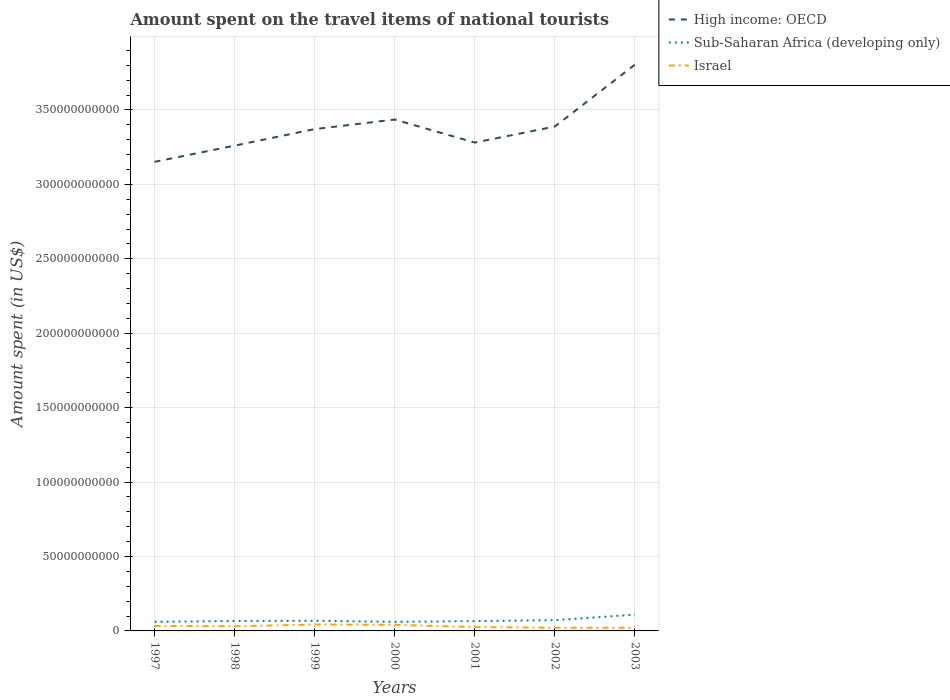How many different coloured lines are there?
Ensure brevity in your answer.  3. Is the number of lines equal to the number of legend labels?
Make the answer very short. Yes. Across all years, what is the maximum amount spent on the travel items of national tourists in Israel?
Offer a terse response. 2.13e+09. In which year was the amount spent on the travel items of national tourists in Israel maximum?
Your answer should be compact. 2003. What is the total amount spent on the travel items of national tourists in Israel in the graph?
Offer a very short reply. -1.15e+09. What is the difference between the highest and the second highest amount spent on the travel items of national tourists in Israel?
Ensure brevity in your answer.  2.17e+09. What is the difference between the highest and the lowest amount spent on the travel items of national tourists in Israel?
Offer a very short reply. 4. How many years are there in the graph?
Your answer should be compact. 7. What is the difference between two consecutive major ticks on the Y-axis?
Your answer should be compact. 5.00e+1. How many legend labels are there?
Provide a short and direct response. 3. How are the legend labels stacked?
Your response must be concise. Vertical. What is the title of the graph?
Give a very brief answer. Amount spent on the travel items of national tourists. What is the label or title of the Y-axis?
Offer a very short reply. Amount spent (in US$). What is the Amount spent (in US$) of High income: OECD in 1997?
Offer a terse response. 3.15e+11. What is the Amount spent (in US$) of Sub-Saharan Africa (developing only) in 1997?
Provide a short and direct response. 6.13e+09. What is the Amount spent (in US$) of Israel in 1997?
Ensure brevity in your answer.  3.30e+09. What is the Amount spent (in US$) of High income: OECD in 1998?
Make the answer very short. 3.26e+11. What is the Amount spent (in US$) in Sub-Saharan Africa (developing only) in 1998?
Keep it short and to the point. 6.64e+09. What is the Amount spent (in US$) in Israel in 1998?
Offer a very short reply. 3.16e+09. What is the Amount spent (in US$) of High income: OECD in 1999?
Make the answer very short. 3.37e+11. What is the Amount spent (in US$) in Sub-Saharan Africa (developing only) in 1999?
Your answer should be very brief. 6.82e+09. What is the Amount spent (in US$) in Israel in 1999?
Offer a very short reply. 4.30e+09. What is the Amount spent (in US$) in High income: OECD in 2000?
Provide a succinct answer. 3.44e+11. What is the Amount spent (in US$) in Sub-Saharan Africa (developing only) in 2000?
Your answer should be very brief. 6.09e+09. What is the Amount spent (in US$) of Israel in 2000?
Provide a short and direct response. 4.11e+09. What is the Amount spent (in US$) of High income: OECD in 2001?
Offer a very short reply. 3.28e+11. What is the Amount spent (in US$) in Sub-Saharan Africa (developing only) in 2001?
Ensure brevity in your answer.  6.57e+09. What is the Amount spent (in US$) of Israel in 2001?
Offer a very short reply. 2.56e+09. What is the Amount spent (in US$) in High income: OECD in 2002?
Keep it short and to the point. 3.39e+11. What is the Amount spent (in US$) of Sub-Saharan Africa (developing only) in 2002?
Your answer should be compact. 7.24e+09. What is the Amount spent (in US$) of Israel in 2002?
Ensure brevity in your answer.  2.14e+09. What is the Amount spent (in US$) in High income: OECD in 2003?
Make the answer very short. 3.80e+11. What is the Amount spent (in US$) of Sub-Saharan Africa (developing only) in 2003?
Your response must be concise. 1.09e+1. What is the Amount spent (in US$) in Israel in 2003?
Ensure brevity in your answer.  2.13e+09. Across all years, what is the maximum Amount spent (in US$) of High income: OECD?
Give a very brief answer. 3.80e+11. Across all years, what is the maximum Amount spent (in US$) in Sub-Saharan Africa (developing only)?
Your answer should be very brief. 1.09e+1. Across all years, what is the maximum Amount spent (in US$) of Israel?
Your answer should be compact. 4.30e+09. Across all years, what is the minimum Amount spent (in US$) of High income: OECD?
Your answer should be compact. 3.15e+11. Across all years, what is the minimum Amount spent (in US$) of Sub-Saharan Africa (developing only)?
Your answer should be compact. 6.09e+09. Across all years, what is the minimum Amount spent (in US$) in Israel?
Keep it short and to the point. 2.13e+09. What is the total Amount spent (in US$) of High income: OECD in the graph?
Offer a very short reply. 2.37e+12. What is the total Amount spent (in US$) in Sub-Saharan Africa (developing only) in the graph?
Your answer should be very brief. 5.04e+1. What is the total Amount spent (in US$) of Israel in the graph?
Your answer should be very brief. 2.17e+1. What is the difference between the Amount spent (in US$) in High income: OECD in 1997 and that in 1998?
Provide a short and direct response. -1.09e+1. What is the difference between the Amount spent (in US$) of Sub-Saharan Africa (developing only) in 1997 and that in 1998?
Give a very brief answer. -5.08e+08. What is the difference between the Amount spent (in US$) of Israel in 1997 and that in 1998?
Your answer should be very brief. 1.38e+08. What is the difference between the Amount spent (in US$) in High income: OECD in 1997 and that in 1999?
Ensure brevity in your answer.  -2.20e+1. What is the difference between the Amount spent (in US$) of Sub-Saharan Africa (developing only) in 1997 and that in 1999?
Offer a very short reply. -6.85e+08. What is the difference between the Amount spent (in US$) of Israel in 1997 and that in 1999?
Ensure brevity in your answer.  -1.01e+09. What is the difference between the Amount spent (in US$) in High income: OECD in 1997 and that in 2000?
Ensure brevity in your answer.  -2.84e+1. What is the difference between the Amount spent (in US$) in Sub-Saharan Africa (developing only) in 1997 and that in 2000?
Provide a short and direct response. 3.96e+07. What is the difference between the Amount spent (in US$) in Israel in 1997 and that in 2000?
Your response must be concise. -8.19e+08. What is the difference between the Amount spent (in US$) in High income: OECD in 1997 and that in 2001?
Your answer should be very brief. -1.30e+1. What is the difference between the Amount spent (in US$) of Sub-Saharan Africa (developing only) in 1997 and that in 2001?
Your answer should be very brief. -4.36e+08. What is the difference between the Amount spent (in US$) of Israel in 1997 and that in 2001?
Your response must be concise. 7.35e+08. What is the difference between the Amount spent (in US$) of High income: OECD in 1997 and that in 2002?
Provide a succinct answer. -2.37e+1. What is the difference between the Amount spent (in US$) of Sub-Saharan Africa (developing only) in 1997 and that in 2002?
Make the answer very short. -1.10e+09. What is the difference between the Amount spent (in US$) of Israel in 1997 and that in 2002?
Make the answer very short. 1.15e+09. What is the difference between the Amount spent (in US$) in High income: OECD in 1997 and that in 2003?
Provide a succinct answer. -6.53e+1. What is the difference between the Amount spent (in US$) in Sub-Saharan Africa (developing only) in 1997 and that in 2003?
Provide a short and direct response. -4.78e+09. What is the difference between the Amount spent (in US$) of Israel in 1997 and that in 2003?
Offer a terse response. 1.16e+09. What is the difference between the Amount spent (in US$) of High income: OECD in 1998 and that in 1999?
Keep it short and to the point. -1.11e+1. What is the difference between the Amount spent (in US$) in Sub-Saharan Africa (developing only) in 1998 and that in 1999?
Offer a very short reply. -1.77e+08. What is the difference between the Amount spent (in US$) of Israel in 1998 and that in 1999?
Provide a short and direct response. -1.15e+09. What is the difference between the Amount spent (in US$) of High income: OECD in 1998 and that in 2000?
Your response must be concise. -1.75e+1. What is the difference between the Amount spent (in US$) of Sub-Saharan Africa (developing only) in 1998 and that in 2000?
Your answer should be compact. 5.47e+08. What is the difference between the Amount spent (in US$) in Israel in 1998 and that in 2000?
Provide a short and direct response. -9.57e+08. What is the difference between the Amount spent (in US$) of High income: OECD in 1998 and that in 2001?
Keep it short and to the point. -2.06e+09. What is the difference between the Amount spent (in US$) of Sub-Saharan Africa (developing only) in 1998 and that in 2001?
Your answer should be very brief. 7.14e+07. What is the difference between the Amount spent (in US$) in Israel in 1998 and that in 2001?
Offer a terse response. 5.97e+08. What is the difference between the Amount spent (in US$) of High income: OECD in 1998 and that in 2002?
Offer a terse response. -1.28e+1. What is the difference between the Amount spent (in US$) in Sub-Saharan Africa (developing only) in 1998 and that in 2002?
Your answer should be compact. -5.95e+08. What is the difference between the Amount spent (in US$) in Israel in 1998 and that in 2002?
Offer a terse response. 1.01e+09. What is the difference between the Amount spent (in US$) of High income: OECD in 1998 and that in 2003?
Keep it short and to the point. -5.44e+1. What is the difference between the Amount spent (in US$) of Sub-Saharan Africa (developing only) in 1998 and that in 2003?
Offer a terse response. -4.27e+09. What is the difference between the Amount spent (in US$) in Israel in 1998 and that in 2003?
Ensure brevity in your answer.  1.02e+09. What is the difference between the Amount spent (in US$) of High income: OECD in 1999 and that in 2000?
Give a very brief answer. -6.42e+09. What is the difference between the Amount spent (in US$) in Sub-Saharan Africa (developing only) in 1999 and that in 2000?
Your response must be concise. 7.25e+08. What is the difference between the Amount spent (in US$) in Israel in 1999 and that in 2000?
Give a very brief answer. 1.90e+08. What is the difference between the Amount spent (in US$) of High income: OECD in 1999 and that in 2001?
Give a very brief answer. 9.06e+09. What is the difference between the Amount spent (in US$) of Sub-Saharan Africa (developing only) in 1999 and that in 2001?
Provide a succinct answer. 2.49e+08. What is the difference between the Amount spent (in US$) in Israel in 1999 and that in 2001?
Your answer should be very brief. 1.74e+09. What is the difference between the Amount spent (in US$) of High income: OECD in 1999 and that in 2002?
Ensure brevity in your answer.  -1.72e+09. What is the difference between the Amount spent (in US$) of Sub-Saharan Africa (developing only) in 1999 and that in 2002?
Ensure brevity in your answer.  -4.17e+08. What is the difference between the Amount spent (in US$) of Israel in 1999 and that in 2002?
Offer a terse response. 2.16e+09. What is the difference between the Amount spent (in US$) in High income: OECD in 1999 and that in 2003?
Give a very brief answer. -4.32e+1. What is the difference between the Amount spent (in US$) in Sub-Saharan Africa (developing only) in 1999 and that in 2003?
Offer a terse response. -4.10e+09. What is the difference between the Amount spent (in US$) in Israel in 1999 and that in 2003?
Offer a very short reply. 2.17e+09. What is the difference between the Amount spent (in US$) in High income: OECD in 2000 and that in 2001?
Give a very brief answer. 1.55e+1. What is the difference between the Amount spent (in US$) in Sub-Saharan Africa (developing only) in 2000 and that in 2001?
Offer a very short reply. -4.76e+08. What is the difference between the Amount spent (in US$) in Israel in 2000 and that in 2001?
Your answer should be compact. 1.55e+09. What is the difference between the Amount spent (in US$) of High income: OECD in 2000 and that in 2002?
Your answer should be compact. 4.70e+09. What is the difference between the Amount spent (in US$) of Sub-Saharan Africa (developing only) in 2000 and that in 2002?
Your answer should be compact. -1.14e+09. What is the difference between the Amount spent (in US$) of Israel in 2000 and that in 2002?
Ensure brevity in your answer.  1.97e+09. What is the difference between the Amount spent (in US$) in High income: OECD in 2000 and that in 2003?
Ensure brevity in your answer.  -3.68e+1. What is the difference between the Amount spent (in US$) in Sub-Saharan Africa (developing only) in 2000 and that in 2003?
Provide a short and direct response. -4.82e+09. What is the difference between the Amount spent (in US$) of Israel in 2000 and that in 2003?
Your answer should be compact. 1.98e+09. What is the difference between the Amount spent (in US$) of High income: OECD in 2001 and that in 2002?
Provide a succinct answer. -1.08e+1. What is the difference between the Amount spent (in US$) in Sub-Saharan Africa (developing only) in 2001 and that in 2002?
Give a very brief answer. -6.66e+08. What is the difference between the Amount spent (in US$) in Israel in 2001 and that in 2002?
Keep it short and to the point. 4.15e+08. What is the difference between the Amount spent (in US$) of High income: OECD in 2001 and that in 2003?
Keep it short and to the point. -5.23e+1. What is the difference between the Amount spent (in US$) of Sub-Saharan Africa (developing only) in 2001 and that in 2003?
Provide a short and direct response. -4.34e+09. What is the difference between the Amount spent (in US$) in Israel in 2001 and that in 2003?
Make the answer very short. 4.28e+08. What is the difference between the Amount spent (in US$) of High income: OECD in 2002 and that in 2003?
Ensure brevity in your answer.  -4.15e+1. What is the difference between the Amount spent (in US$) of Sub-Saharan Africa (developing only) in 2002 and that in 2003?
Your response must be concise. -3.68e+09. What is the difference between the Amount spent (in US$) of Israel in 2002 and that in 2003?
Provide a short and direct response. 1.30e+07. What is the difference between the Amount spent (in US$) of High income: OECD in 1997 and the Amount spent (in US$) of Sub-Saharan Africa (developing only) in 1998?
Provide a short and direct response. 3.08e+11. What is the difference between the Amount spent (in US$) of High income: OECD in 1997 and the Amount spent (in US$) of Israel in 1998?
Your answer should be compact. 3.12e+11. What is the difference between the Amount spent (in US$) of Sub-Saharan Africa (developing only) in 1997 and the Amount spent (in US$) of Israel in 1998?
Offer a very short reply. 2.98e+09. What is the difference between the Amount spent (in US$) of High income: OECD in 1997 and the Amount spent (in US$) of Sub-Saharan Africa (developing only) in 1999?
Ensure brevity in your answer.  3.08e+11. What is the difference between the Amount spent (in US$) of High income: OECD in 1997 and the Amount spent (in US$) of Israel in 1999?
Keep it short and to the point. 3.11e+11. What is the difference between the Amount spent (in US$) in Sub-Saharan Africa (developing only) in 1997 and the Amount spent (in US$) in Israel in 1999?
Provide a short and direct response. 1.83e+09. What is the difference between the Amount spent (in US$) in High income: OECD in 1997 and the Amount spent (in US$) in Sub-Saharan Africa (developing only) in 2000?
Ensure brevity in your answer.  3.09e+11. What is the difference between the Amount spent (in US$) of High income: OECD in 1997 and the Amount spent (in US$) of Israel in 2000?
Your answer should be very brief. 3.11e+11. What is the difference between the Amount spent (in US$) in Sub-Saharan Africa (developing only) in 1997 and the Amount spent (in US$) in Israel in 2000?
Provide a succinct answer. 2.02e+09. What is the difference between the Amount spent (in US$) in High income: OECD in 1997 and the Amount spent (in US$) in Sub-Saharan Africa (developing only) in 2001?
Make the answer very short. 3.09e+11. What is the difference between the Amount spent (in US$) of High income: OECD in 1997 and the Amount spent (in US$) of Israel in 2001?
Your response must be concise. 3.13e+11. What is the difference between the Amount spent (in US$) of Sub-Saharan Africa (developing only) in 1997 and the Amount spent (in US$) of Israel in 2001?
Provide a succinct answer. 3.57e+09. What is the difference between the Amount spent (in US$) of High income: OECD in 1997 and the Amount spent (in US$) of Sub-Saharan Africa (developing only) in 2002?
Ensure brevity in your answer.  3.08e+11. What is the difference between the Amount spent (in US$) in High income: OECD in 1997 and the Amount spent (in US$) in Israel in 2002?
Keep it short and to the point. 3.13e+11. What is the difference between the Amount spent (in US$) of Sub-Saharan Africa (developing only) in 1997 and the Amount spent (in US$) of Israel in 2002?
Ensure brevity in your answer.  3.99e+09. What is the difference between the Amount spent (in US$) of High income: OECD in 1997 and the Amount spent (in US$) of Sub-Saharan Africa (developing only) in 2003?
Provide a succinct answer. 3.04e+11. What is the difference between the Amount spent (in US$) in High income: OECD in 1997 and the Amount spent (in US$) in Israel in 2003?
Your answer should be compact. 3.13e+11. What is the difference between the Amount spent (in US$) of Sub-Saharan Africa (developing only) in 1997 and the Amount spent (in US$) of Israel in 2003?
Offer a very short reply. 4.00e+09. What is the difference between the Amount spent (in US$) of High income: OECD in 1998 and the Amount spent (in US$) of Sub-Saharan Africa (developing only) in 1999?
Your answer should be compact. 3.19e+11. What is the difference between the Amount spent (in US$) of High income: OECD in 1998 and the Amount spent (in US$) of Israel in 1999?
Offer a terse response. 3.22e+11. What is the difference between the Amount spent (in US$) in Sub-Saharan Africa (developing only) in 1998 and the Amount spent (in US$) in Israel in 1999?
Your answer should be compact. 2.34e+09. What is the difference between the Amount spent (in US$) in High income: OECD in 1998 and the Amount spent (in US$) in Sub-Saharan Africa (developing only) in 2000?
Your answer should be compact. 3.20e+11. What is the difference between the Amount spent (in US$) of High income: OECD in 1998 and the Amount spent (in US$) of Israel in 2000?
Give a very brief answer. 3.22e+11. What is the difference between the Amount spent (in US$) in Sub-Saharan Africa (developing only) in 1998 and the Amount spent (in US$) in Israel in 2000?
Give a very brief answer. 2.53e+09. What is the difference between the Amount spent (in US$) of High income: OECD in 1998 and the Amount spent (in US$) of Sub-Saharan Africa (developing only) in 2001?
Provide a succinct answer. 3.19e+11. What is the difference between the Amount spent (in US$) of High income: OECD in 1998 and the Amount spent (in US$) of Israel in 2001?
Give a very brief answer. 3.23e+11. What is the difference between the Amount spent (in US$) of Sub-Saharan Africa (developing only) in 1998 and the Amount spent (in US$) of Israel in 2001?
Offer a terse response. 4.08e+09. What is the difference between the Amount spent (in US$) of High income: OECD in 1998 and the Amount spent (in US$) of Sub-Saharan Africa (developing only) in 2002?
Your answer should be compact. 3.19e+11. What is the difference between the Amount spent (in US$) in High income: OECD in 1998 and the Amount spent (in US$) in Israel in 2002?
Make the answer very short. 3.24e+11. What is the difference between the Amount spent (in US$) of Sub-Saharan Africa (developing only) in 1998 and the Amount spent (in US$) of Israel in 2002?
Offer a terse response. 4.50e+09. What is the difference between the Amount spent (in US$) of High income: OECD in 1998 and the Amount spent (in US$) of Sub-Saharan Africa (developing only) in 2003?
Offer a terse response. 3.15e+11. What is the difference between the Amount spent (in US$) of High income: OECD in 1998 and the Amount spent (in US$) of Israel in 2003?
Ensure brevity in your answer.  3.24e+11. What is the difference between the Amount spent (in US$) of Sub-Saharan Africa (developing only) in 1998 and the Amount spent (in US$) of Israel in 2003?
Offer a very short reply. 4.51e+09. What is the difference between the Amount spent (in US$) of High income: OECD in 1999 and the Amount spent (in US$) of Sub-Saharan Africa (developing only) in 2000?
Ensure brevity in your answer.  3.31e+11. What is the difference between the Amount spent (in US$) of High income: OECD in 1999 and the Amount spent (in US$) of Israel in 2000?
Provide a succinct answer. 3.33e+11. What is the difference between the Amount spent (in US$) of Sub-Saharan Africa (developing only) in 1999 and the Amount spent (in US$) of Israel in 2000?
Your answer should be compact. 2.70e+09. What is the difference between the Amount spent (in US$) in High income: OECD in 1999 and the Amount spent (in US$) in Sub-Saharan Africa (developing only) in 2001?
Keep it short and to the point. 3.31e+11. What is the difference between the Amount spent (in US$) of High income: OECD in 1999 and the Amount spent (in US$) of Israel in 2001?
Give a very brief answer. 3.35e+11. What is the difference between the Amount spent (in US$) of Sub-Saharan Africa (developing only) in 1999 and the Amount spent (in US$) of Israel in 2001?
Offer a terse response. 4.26e+09. What is the difference between the Amount spent (in US$) in High income: OECD in 1999 and the Amount spent (in US$) in Sub-Saharan Africa (developing only) in 2002?
Provide a short and direct response. 3.30e+11. What is the difference between the Amount spent (in US$) of High income: OECD in 1999 and the Amount spent (in US$) of Israel in 2002?
Offer a terse response. 3.35e+11. What is the difference between the Amount spent (in US$) of Sub-Saharan Africa (developing only) in 1999 and the Amount spent (in US$) of Israel in 2002?
Your answer should be compact. 4.67e+09. What is the difference between the Amount spent (in US$) of High income: OECD in 1999 and the Amount spent (in US$) of Sub-Saharan Africa (developing only) in 2003?
Keep it short and to the point. 3.26e+11. What is the difference between the Amount spent (in US$) in High income: OECD in 1999 and the Amount spent (in US$) in Israel in 2003?
Offer a very short reply. 3.35e+11. What is the difference between the Amount spent (in US$) in Sub-Saharan Africa (developing only) in 1999 and the Amount spent (in US$) in Israel in 2003?
Give a very brief answer. 4.69e+09. What is the difference between the Amount spent (in US$) of High income: OECD in 2000 and the Amount spent (in US$) of Sub-Saharan Africa (developing only) in 2001?
Your answer should be compact. 3.37e+11. What is the difference between the Amount spent (in US$) in High income: OECD in 2000 and the Amount spent (in US$) in Israel in 2001?
Your answer should be very brief. 3.41e+11. What is the difference between the Amount spent (in US$) of Sub-Saharan Africa (developing only) in 2000 and the Amount spent (in US$) of Israel in 2001?
Your answer should be compact. 3.53e+09. What is the difference between the Amount spent (in US$) of High income: OECD in 2000 and the Amount spent (in US$) of Sub-Saharan Africa (developing only) in 2002?
Provide a short and direct response. 3.36e+11. What is the difference between the Amount spent (in US$) of High income: OECD in 2000 and the Amount spent (in US$) of Israel in 2002?
Make the answer very short. 3.41e+11. What is the difference between the Amount spent (in US$) of Sub-Saharan Africa (developing only) in 2000 and the Amount spent (in US$) of Israel in 2002?
Offer a terse response. 3.95e+09. What is the difference between the Amount spent (in US$) of High income: OECD in 2000 and the Amount spent (in US$) of Sub-Saharan Africa (developing only) in 2003?
Your response must be concise. 3.33e+11. What is the difference between the Amount spent (in US$) in High income: OECD in 2000 and the Amount spent (in US$) in Israel in 2003?
Your response must be concise. 3.41e+11. What is the difference between the Amount spent (in US$) of Sub-Saharan Africa (developing only) in 2000 and the Amount spent (in US$) of Israel in 2003?
Offer a very short reply. 3.96e+09. What is the difference between the Amount spent (in US$) of High income: OECD in 2001 and the Amount spent (in US$) of Sub-Saharan Africa (developing only) in 2002?
Your answer should be compact. 3.21e+11. What is the difference between the Amount spent (in US$) in High income: OECD in 2001 and the Amount spent (in US$) in Israel in 2002?
Your answer should be compact. 3.26e+11. What is the difference between the Amount spent (in US$) in Sub-Saharan Africa (developing only) in 2001 and the Amount spent (in US$) in Israel in 2002?
Ensure brevity in your answer.  4.42e+09. What is the difference between the Amount spent (in US$) of High income: OECD in 2001 and the Amount spent (in US$) of Sub-Saharan Africa (developing only) in 2003?
Your response must be concise. 3.17e+11. What is the difference between the Amount spent (in US$) of High income: OECD in 2001 and the Amount spent (in US$) of Israel in 2003?
Give a very brief answer. 3.26e+11. What is the difference between the Amount spent (in US$) in Sub-Saharan Africa (developing only) in 2001 and the Amount spent (in US$) in Israel in 2003?
Offer a terse response. 4.44e+09. What is the difference between the Amount spent (in US$) of High income: OECD in 2002 and the Amount spent (in US$) of Sub-Saharan Africa (developing only) in 2003?
Offer a very short reply. 3.28e+11. What is the difference between the Amount spent (in US$) of High income: OECD in 2002 and the Amount spent (in US$) of Israel in 2003?
Provide a short and direct response. 3.37e+11. What is the difference between the Amount spent (in US$) in Sub-Saharan Africa (developing only) in 2002 and the Amount spent (in US$) in Israel in 2003?
Make the answer very short. 5.10e+09. What is the average Amount spent (in US$) of High income: OECD per year?
Keep it short and to the point. 3.38e+11. What is the average Amount spent (in US$) in Sub-Saharan Africa (developing only) per year?
Make the answer very short. 7.20e+09. What is the average Amount spent (in US$) in Israel per year?
Ensure brevity in your answer.  3.10e+09. In the year 1997, what is the difference between the Amount spent (in US$) of High income: OECD and Amount spent (in US$) of Sub-Saharan Africa (developing only)?
Keep it short and to the point. 3.09e+11. In the year 1997, what is the difference between the Amount spent (in US$) in High income: OECD and Amount spent (in US$) in Israel?
Offer a very short reply. 3.12e+11. In the year 1997, what is the difference between the Amount spent (in US$) of Sub-Saharan Africa (developing only) and Amount spent (in US$) of Israel?
Ensure brevity in your answer.  2.84e+09. In the year 1998, what is the difference between the Amount spent (in US$) of High income: OECD and Amount spent (in US$) of Sub-Saharan Africa (developing only)?
Make the answer very short. 3.19e+11. In the year 1998, what is the difference between the Amount spent (in US$) of High income: OECD and Amount spent (in US$) of Israel?
Provide a short and direct response. 3.23e+11. In the year 1998, what is the difference between the Amount spent (in US$) in Sub-Saharan Africa (developing only) and Amount spent (in US$) in Israel?
Offer a terse response. 3.48e+09. In the year 1999, what is the difference between the Amount spent (in US$) of High income: OECD and Amount spent (in US$) of Sub-Saharan Africa (developing only)?
Keep it short and to the point. 3.30e+11. In the year 1999, what is the difference between the Amount spent (in US$) of High income: OECD and Amount spent (in US$) of Israel?
Your answer should be very brief. 3.33e+11. In the year 1999, what is the difference between the Amount spent (in US$) in Sub-Saharan Africa (developing only) and Amount spent (in US$) in Israel?
Your response must be concise. 2.51e+09. In the year 2000, what is the difference between the Amount spent (in US$) of High income: OECD and Amount spent (in US$) of Sub-Saharan Africa (developing only)?
Make the answer very short. 3.37e+11. In the year 2000, what is the difference between the Amount spent (in US$) of High income: OECD and Amount spent (in US$) of Israel?
Keep it short and to the point. 3.39e+11. In the year 2000, what is the difference between the Amount spent (in US$) of Sub-Saharan Africa (developing only) and Amount spent (in US$) of Israel?
Make the answer very short. 1.98e+09. In the year 2001, what is the difference between the Amount spent (in US$) in High income: OECD and Amount spent (in US$) in Sub-Saharan Africa (developing only)?
Your response must be concise. 3.21e+11. In the year 2001, what is the difference between the Amount spent (in US$) in High income: OECD and Amount spent (in US$) in Israel?
Provide a short and direct response. 3.26e+11. In the year 2001, what is the difference between the Amount spent (in US$) of Sub-Saharan Africa (developing only) and Amount spent (in US$) of Israel?
Your answer should be compact. 4.01e+09. In the year 2002, what is the difference between the Amount spent (in US$) in High income: OECD and Amount spent (in US$) in Sub-Saharan Africa (developing only)?
Provide a succinct answer. 3.32e+11. In the year 2002, what is the difference between the Amount spent (in US$) of High income: OECD and Amount spent (in US$) of Israel?
Offer a very short reply. 3.37e+11. In the year 2002, what is the difference between the Amount spent (in US$) of Sub-Saharan Africa (developing only) and Amount spent (in US$) of Israel?
Keep it short and to the point. 5.09e+09. In the year 2003, what is the difference between the Amount spent (in US$) in High income: OECD and Amount spent (in US$) in Sub-Saharan Africa (developing only)?
Your answer should be compact. 3.69e+11. In the year 2003, what is the difference between the Amount spent (in US$) of High income: OECD and Amount spent (in US$) of Israel?
Your answer should be compact. 3.78e+11. In the year 2003, what is the difference between the Amount spent (in US$) in Sub-Saharan Africa (developing only) and Amount spent (in US$) in Israel?
Make the answer very short. 8.78e+09. What is the ratio of the Amount spent (in US$) of High income: OECD in 1997 to that in 1998?
Keep it short and to the point. 0.97. What is the ratio of the Amount spent (in US$) in Sub-Saharan Africa (developing only) in 1997 to that in 1998?
Offer a very short reply. 0.92. What is the ratio of the Amount spent (in US$) of Israel in 1997 to that in 1998?
Provide a short and direct response. 1.04. What is the ratio of the Amount spent (in US$) of High income: OECD in 1997 to that in 1999?
Provide a short and direct response. 0.93. What is the ratio of the Amount spent (in US$) in Sub-Saharan Africa (developing only) in 1997 to that in 1999?
Provide a short and direct response. 0.9. What is the ratio of the Amount spent (in US$) of Israel in 1997 to that in 1999?
Your response must be concise. 0.77. What is the ratio of the Amount spent (in US$) in High income: OECD in 1997 to that in 2000?
Your answer should be compact. 0.92. What is the ratio of the Amount spent (in US$) of Israel in 1997 to that in 2000?
Ensure brevity in your answer.  0.8. What is the ratio of the Amount spent (in US$) of High income: OECD in 1997 to that in 2001?
Make the answer very short. 0.96. What is the ratio of the Amount spent (in US$) in Sub-Saharan Africa (developing only) in 1997 to that in 2001?
Make the answer very short. 0.93. What is the ratio of the Amount spent (in US$) in Israel in 1997 to that in 2001?
Offer a terse response. 1.29. What is the ratio of the Amount spent (in US$) in High income: OECD in 1997 to that in 2002?
Your answer should be very brief. 0.93. What is the ratio of the Amount spent (in US$) of Sub-Saharan Africa (developing only) in 1997 to that in 2002?
Provide a succinct answer. 0.85. What is the ratio of the Amount spent (in US$) of Israel in 1997 to that in 2002?
Keep it short and to the point. 1.54. What is the ratio of the Amount spent (in US$) in High income: OECD in 1997 to that in 2003?
Keep it short and to the point. 0.83. What is the ratio of the Amount spent (in US$) in Sub-Saharan Africa (developing only) in 1997 to that in 2003?
Offer a terse response. 0.56. What is the ratio of the Amount spent (in US$) in Israel in 1997 to that in 2003?
Ensure brevity in your answer.  1.55. What is the ratio of the Amount spent (in US$) of High income: OECD in 1998 to that in 1999?
Ensure brevity in your answer.  0.97. What is the ratio of the Amount spent (in US$) in Israel in 1998 to that in 1999?
Keep it short and to the point. 0.73. What is the ratio of the Amount spent (in US$) in High income: OECD in 1998 to that in 2000?
Give a very brief answer. 0.95. What is the ratio of the Amount spent (in US$) of Sub-Saharan Africa (developing only) in 1998 to that in 2000?
Provide a succinct answer. 1.09. What is the ratio of the Amount spent (in US$) in Israel in 1998 to that in 2000?
Offer a terse response. 0.77. What is the ratio of the Amount spent (in US$) in High income: OECD in 1998 to that in 2001?
Provide a short and direct response. 0.99. What is the ratio of the Amount spent (in US$) in Sub-Saharan Africa (developing only) in 1998 to that in 2001?
Provide a short and direct response. 1.01. What is the ratio of the Amount spent (in US$) of Israel in 1998 to that in 2001?
Make the answer very short. 1.23. What is the ratio of the Amount spent (in US$) in High income: OECD in 1998 to that in 2002?
Keep it short and to the point. 0.96. What is the ratio of the Amount spent (in US$) in Sub-Saharan Africa (developing only) in 1998 to that in 2002?
Ensure brevity in your answer.  0.92. What is the ratio of the Amount spent (in US$) of Israel in 1998 to that in 2002?
Provide a short and direct response. 1.47. What is the ratio of the Amount spent (in US$) of High income: OECD in 1998 to that in 2003?
Provide a short and direct response. 0.86. What is the ratio of the Amount spent (in US$) of Sub-Saharan Africa (developing only) in 1998 to that in 2003?
Make the answer very short. 0.61. What is the ratio of the Amount spent (in US$) in Israel in 1998 to that in 2003?
Your answer should be compact. 1.48. What is the ratio of the Amount spent (in US$) of High income: OECD in 1999 to that in 2000?
Offer a terse response. 0.98. What is the ratio of the Amount spent (in US$) in Sub-Saharan Africa (developing only) in 1999 to that in 2000?
Your response must be concise. 1.12. What is the ratio of the Amount spent (in US$) of Israel in 1999 to that in 2000?
Make the answer very short. 1.05. What is the ratio of the Amount spent (in US$) of High income: OECD in 1999 to that in 2001?
Keep it short and to the point. 1.03. What is the ratio of the Amount spent (in US$) in Sub-Saharan Africa (developing only) in 1999 to that in 2001?
Ensure brevity in your answer.  1.04. What is the ratio of the Amount spent (in US$) of Israel in 1999 to that in 2001?
Your answer should be very brief. 1.68. What is the ratio of the Amount spent (in US$) of High income: OECD in 1999 to that in 2002?
Ensure brevity in your answer.  0.99. What is the ratio of the Amount spent (in US$) of Sub-Saharan Africa (developing only) in 1999 to that in 2002?
Your response must be concise. 0.94. What is the ratio of the Amount spent (in US$) of Israel in 1999 to that in 2002?
Ensure brevity in your answer.  2.01. What is the ratio of the Amount spent (in US$) in High income: OECD in 1999 to that in 2003?
Ensure brevity in your answer.  0.89. What is the ratio of the Amount spent (in US$) of Sub-Saharan Africa (developing only) in 1999 to that in 2003?
Your answer should be compact. 0.62. What is the ratio of the Amount spent (in US$) in Israel in 1999 to that in 2003?
Provide a succinct answer. 2.02. What is the ratio of the Amount spent (in US$) in High income: OECD in 2000 to that in 2001?
Provide a succinct answer. 1.05. What is the ratio of the Amount spent (in US$) of Sub-Saharan Africa (developing only) in 2000 to that in 2001?
Your response must be concise. 0.93. What is the ratio of the Amount spent (in US$) in Israel in 2000 to that in 2001?
Offer a terse response. 1.61. What is the ratio of the Amount spent (in US$) of High income: OECD in 2000 to that in 2002?
Provide a short and direct response. 1.01. What is the ratio of the Amount spent (in US$) in Sub-Saharan Africa (developing only) in 2000 to that in 2002?
Provide a short and direct response. 0.84. What is the ratio of the Amount spent (in US$) of Israel in 2000 to that in 2002?
Provide a succinct answer. 1.92. What is the ratio of the Amount spent (in US$) in High income: OECD in 2000 to that in 2003?
Ensure brevity in your answer.  0.9. What is the ratio of the Amount spent (in US$) in Sub-Saharan Africa (developing only) in 2000 to that in 2003?
Give a very brief answer. 0.56. What is the ratio of the Amount spent (in US$) in Israel in 2000 to that in 2003?
Your answer should be compact. 1.93. What is the ratio of the Amount spent (in US$) of High income: OECD in 2001 to that in 2002?
Keep it short and to the point. 0.97. What is the ratio of the Amount spent (in US$) of Sub-Saharan Africa (developing only) in 2001 to that in 2002?
Offer a very short reply. 0.91. What is the ratio of the Amount spent (in US$) in Israel in 2001 to that in 2002?
Your answer should be compact. 1.19. What is the ratio of the Amount spent (in US$) of High income: OECD in 2001 to that in 2003?
Your answer should be compact. 0.86. What is the ratio of the Amount spent (in US$) of Sub-Saharan Africa (developing only) in 2001 to that in 2003?
Offer a terse response. 0.6. What is the ratio of the Amount spent (in US$) in Israel in 2001 to that in 2003?
Your answer should be very brief. 1.2. What is the ratio of the Amount spent (in US$) of High income: OECD in 2002 to that in 2003?
Offer a very short reply. 0.89. What is the ratio of the Amount spent (in US$) in Sub-Saharan Africa (developing only) in 2002 to that in 2003?
Ensure brevity in your answer.  0.66. What is the difference between the highest and the second highest Amount spent (in US$) of High income: OECD?
Your answer should be very brief. 3.68e+1. What is the difference between the highest and the second highest Amount spent (in US$) in Sub-Saharan Africa (developing only)?
Offer a very short reply. 3.68e+09. What is the difference between the highest and the second highest Amount spent (in US$) in Israel?
Make the answer very short. 1.90e+08. What is the difference between the highest and the lowest Amount spent (in US$) of High income: OECD?
Offer a terse response. 6.53e+1. What is the difference between the highest and the lowest Amount spent (in US$) in Sub-Saharan Africa (developing only)?
Keep it short and to the point. 4.82e+09. What is the difference between the highest and the lowest Amount spent (in US$) of Israel?
Make the answer very short. 2.17e+09. 